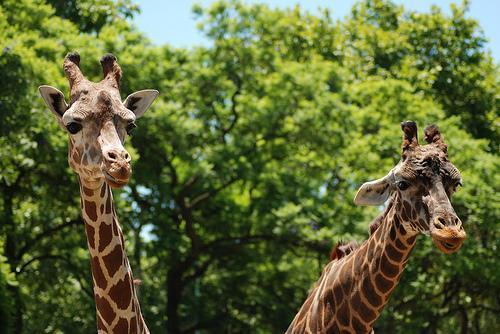How many people are riding on elephants?
Give a very brief answer. 0. How many elephants are pictured?
Give a very brief answer. 0. 